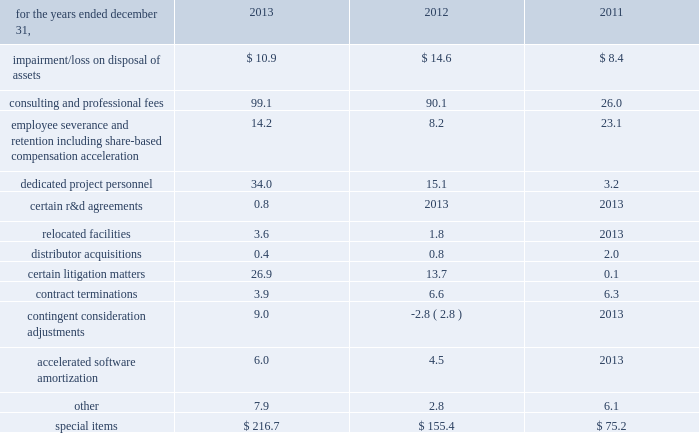Zimmer holdings , inc .
2013 form 10-k annual report notes to consolidated financial statements ( continued ) fees paid to collaborative partners .
Where contingent milestone payments are due to third parties under research and development arrangements , the milestone payment obligations are expensed when the milestone results are achieved .
Litigation 2013 we record a liability for contingent losses , including future legal costs , settlements and judgments , when we consider it is probable that a liability has been incurred and the amount of the loss can be reasonably estimated .
Special items 2013 we recognize expenses resulting directly from our business combinations , employee termination benefits , certain r&d agreements , certain contract terminations , consulting and professional fees and asset impairment or loss on disposal charges connected with global restructuring , operational and quality excellence initiatives , and other items as 201cspecial items 201d in our consolidated statement of earnings .
201cspecial items 201d included ( in millions ) : .
Impairment/ loss on disposal of assets relates to impairment of intangible assets that were acquired in business combinations or impairment of or a loss on the disposal of other assets .
Consulting and professional fees relate to third-party consulting , professional fees and contract labor related to our quality and operational excellence initiatives , third-party consulting fees related to certain information system implementations , third-party integration consulting performed in a variety of areas such as tax , compliance , logistics and human resources for our business combinations , third-party fees related to severance and termination benefits matters and legal fees related to certain product liability matters .
Our quality and operational excellence initiatives are company- wide and include improvements in quality , distribution , sourcing , manufacturing and information technology , among other areas .
In 2013 , 2012 and 2011 , we eliminated positions as we reduced management layers , restructured certain areas , announced closures of certain facilities , and commenced initiatives to focus on business opportunities that best support our strategic priorities .
In 2013 , 2012 and 2011 , approximately 170 , 400 and 500 positions , respectively , from across the globe were affected by these actions .
As a result of these changes in our work force and headcount reductions in connection with acquisitions , we incurred expenses related to severance benefits , redundant salaries as we worked through transition periods , share-based compensation acceleration and other employee termination-related costs .
The majority of these termination benefits were provided in accordance with our existing or local government policies and are considered ongoing benefits .
These costs were accrued when they became probable and estimable and were recorded as part of other current liabilities .
The majority of these costs were paid during the year they were incurred .
Dedicated project personnel expenses include the salary , benefits , travel expenses and other costs directly associated with employees who are 100 percent dedicated to our operational and quality excellence initiatives or integration of acquired businesses .
Certain r&d agreements relate to agreements with upfront payments to obtain intellectual property to be used in r&d projects that have no alternative future use in other projects .
Relocated facilities expenses are the moving costs and the lease expenses incurred during the relocation period in connection with relocating certain facilities .
Over the past few years we have acquired a number of u.s .
And foreign-based distributors .
We have incurred various costs related to the consummation and integration of those businesses .
Certain litigation matters relate to costs and adjustments recognized during the year for the estimated or actual settlement of various legal matters , including royalty disputes , patent litigation matters , commercial litigation matters and matters arising from our acquisitions of certain competitive distributorships in prior years .
Contract termination costs relate to terminated agreements in connection with the integration of acquired companies and changes to our distribution model as part of business restructuring and operational excellence initiatives .
The terminated contracts primarily relate to sales agents and distribution agreements .
Contingent consideration adjustments represent the changes in the fair value of contingent consideration obligations to be paid to the prior owners of acquired businesses .
Accelerated software amortization is the incremental amortization resulting from a reduction in the estimated life of certain software .
In 2012 , we approved a plan to replace certain software .
As a result , the estimated economic useful life of the existing software was decreased to represent the period of time expected to implement replacement software .
As a result , the amortization from the shortened life of this software is substantially higher than the previous amortization being recognized .
Cash and cash equivalents 2013 we consider all highly liquid investments with an original maturity of three months or less to be cash equivalents .
The carrying amounts reported in the balance sheet for cash and cash equivalents are valued at cost , which approximates their fair value. .
What is the percent change in contract terminations from 2011 to 2012? 
Computations: ((6.6 - 6.3) / 6.3)
Answer: 0.04762. 